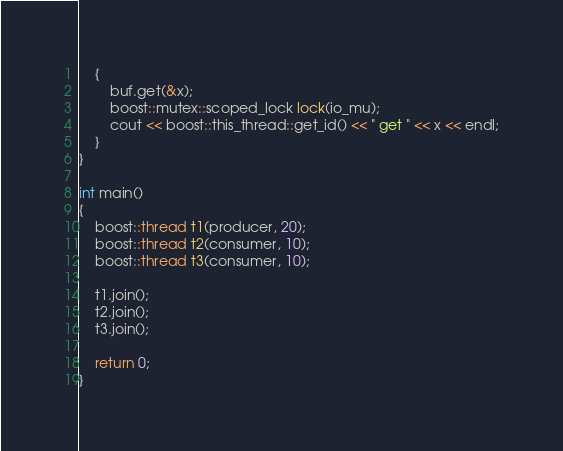<code> <loc_0><loc_0><loc_500><loc_500><_C++_>    {
        buf.get(&x);
        boost::mutex::scoped_lock lock(io_mu);
        cout << boost::this_thread::get_id() << " get " << x << endl;
    }
}

int main()
{
    boost::thread t1(producer, 20);
    boost::thread t2(consumer, 10);
    boost::thread t3(consumer, 10);

    t1.join();
    t2.join();
    t3.join();

    return 0;
}
</code> 